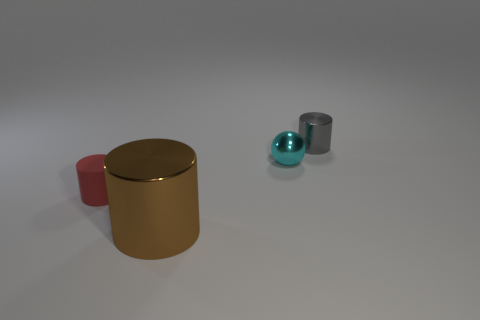Subtract all tiny gray cylinders. How many cylinders are left? 2 Subtract 1 cylinders. How many cylinders are left? 2 Add 2 tiny gray cylinders. How many objects exist? 6 Subtract all cylinders. How many objects are left? 1 Add 1 metallic cylinders. How many metallic cylinders exist? 3 Subtract 0 brown cubes. How many objects are left? 4 Subtract all matte things. Subtract all tiny gray cylinders. How many objects are left? 2 Add 3 tiny shiny balls. How many tiny shiny balls are left? 4 